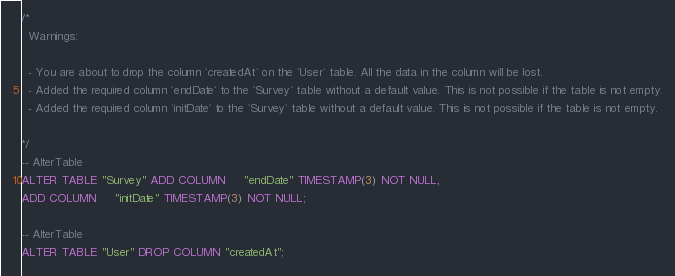Convert code to text. <code><loc_0><loc_0><loc_500><loc_500><_SQL_>/*
  Warnings:

  - You are about to drop the column `createdAt` on the `User` table. All the data in the column will be lost.
  - Added the required column `endDate` to the `Survey` table without a default value. This is not possible if the table is not empty.
  - Added the required column `initDate` to the `Survey` table without a default value. This is not possible if the table is not empty.

*/
-- AlterTable
ALTER TABLE "Survey" ADD COLUMN     "endDate" TIMESTAMP(3) NOT NULL,
ADD COLUMN     "initDate" TIMESTAMP(3) NOT NULL;

-- AlterTable
ALTER TABLE "User" DROP COLUMN "createdAt";
</code> 